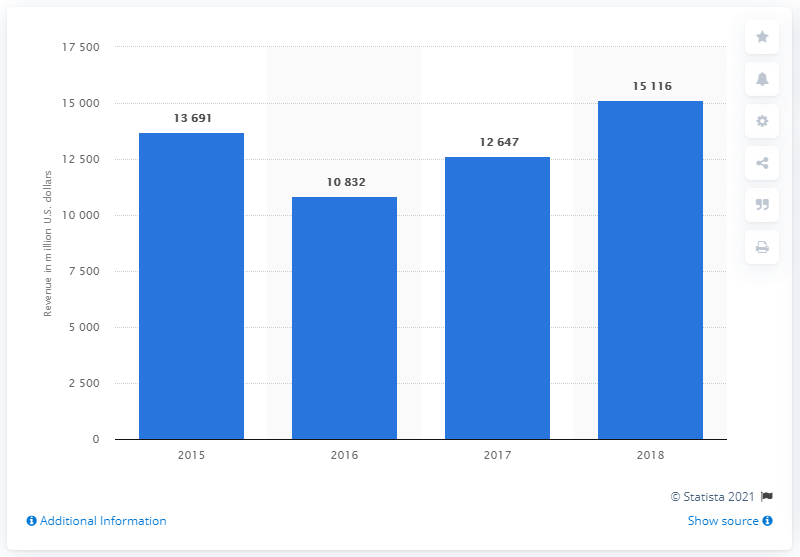Outline some significant characteristics in this image. In 2018, the Industrial Intermediates and Infrastructure segment of DowDuPont generated revenue of $151,168. 